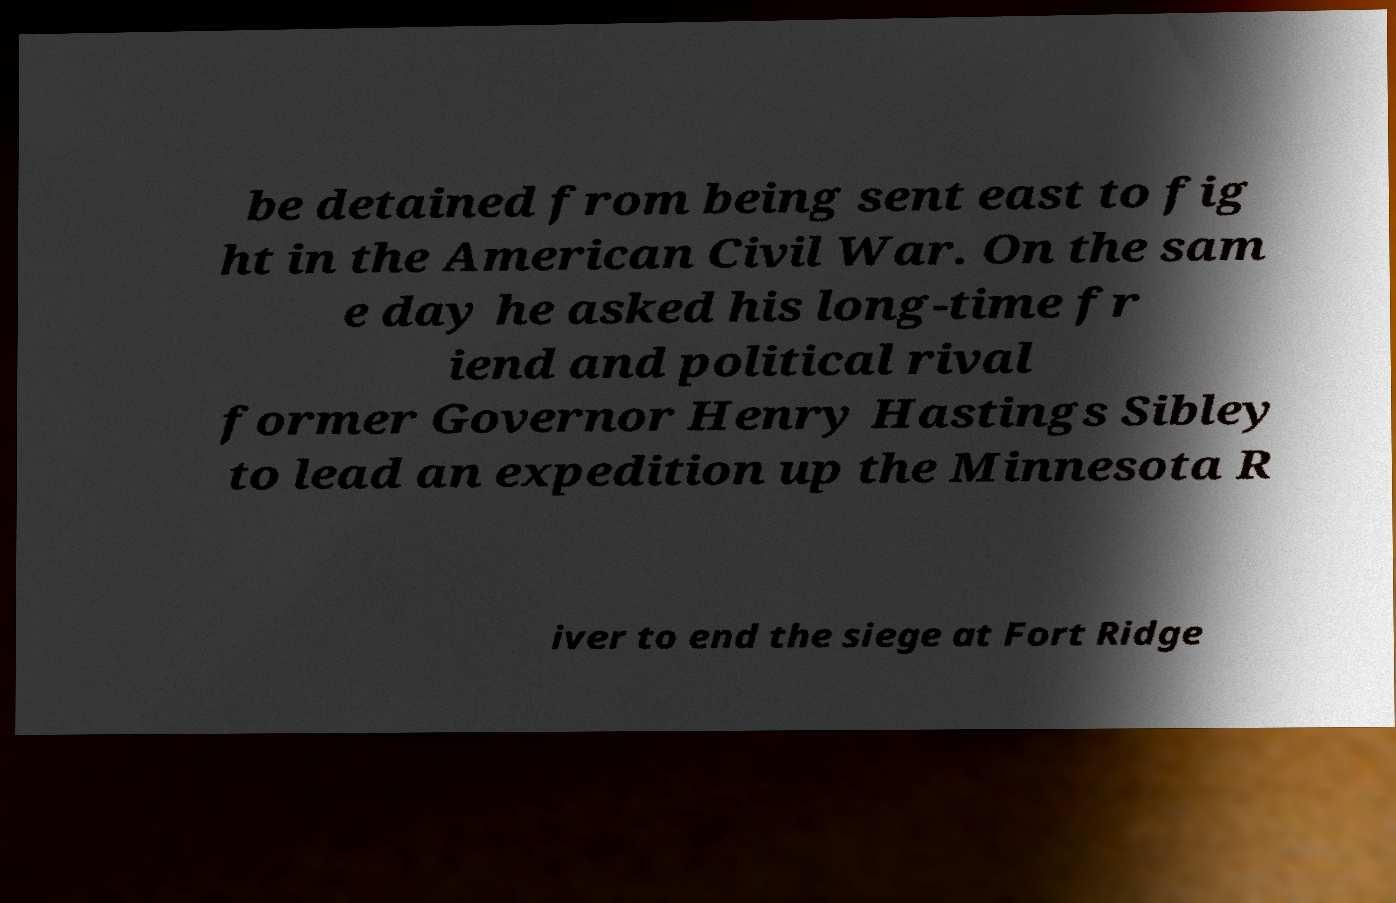Can you accurately transcribe the text from the provided image for me? be detained from being sent east to fig ht in the American Civil War. On the sam e day he asked his long-time fr iend and political rival former Governor Henry Hastings Sibley to lead an expedition up the Minnesota R iver to end the siege at Fort Ridge 